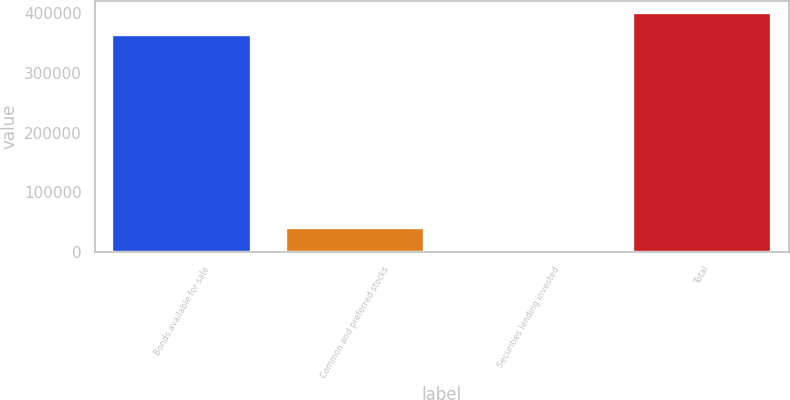Convert chart to OTSL. <chart><loc_0><loc_0><loc_500><loc_500><bar_chart><fcel>Bonds available for sale<fcel>Common and preferred stocks<fcel>Securities lending invested<fcel>Total<nl><fcel>363042<fcel>40587<fcel>3402<fcel>400227<nl></chart> 